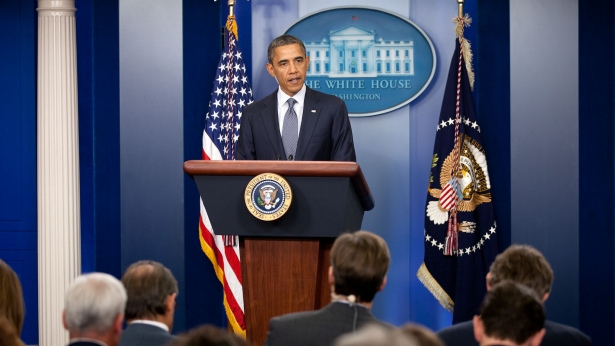Read and extract the text from this image. 4E WHITE HOUSE 